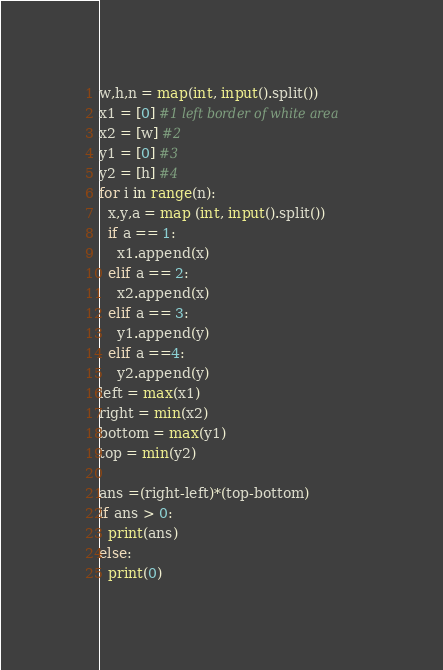<code> <loc_0><loc_0><loc_500><loc_500><_Python_>w,h,n = map(int, input().split())
x1 = [0] #1 left border of white area
x2 = [w] #2
y1 = [0] #3
y2 = [h] #4
for i in range(n):
  x,y,a = map (int, input().split())
  if a == 1:
    x1.append(x)
  elif a == 2:
    x2.append(x)
  elif a == 3:
    y1.append(y)
  elif a ==4:
    y2.append(y)
left = max(x1)
right = min(x2)
bottom = max(y1)
top = min(y2)

ans =(right-left)*(top-bottom)
if ans > 0:
  print(ans)
else:
  print(0)</code> 